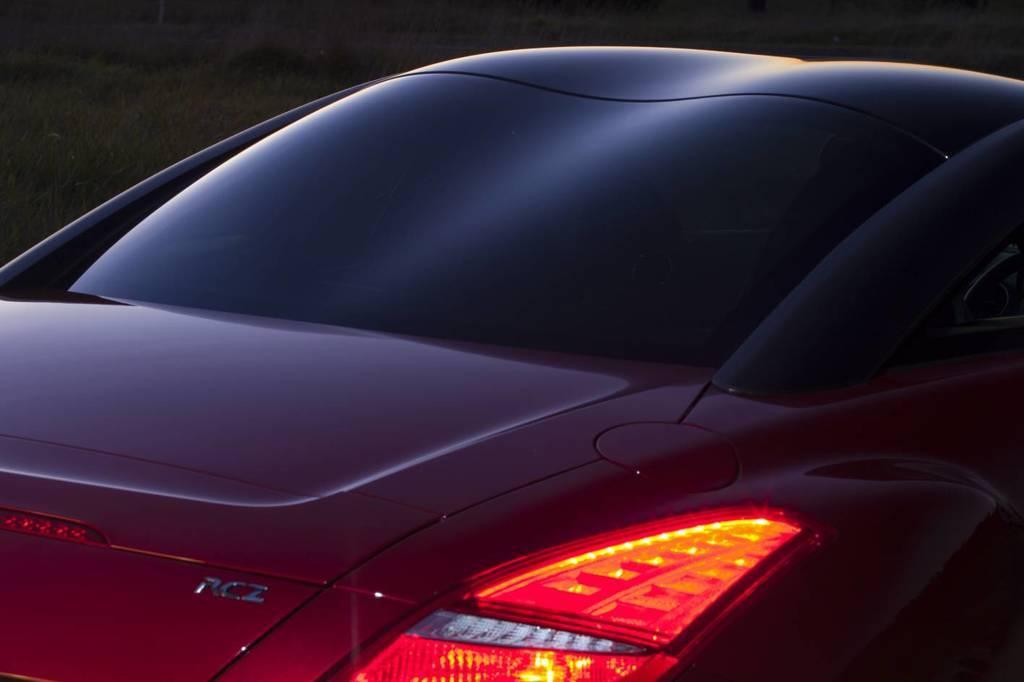Please provide a concise description of this image. In the image there is a car with lights and logo. And also there is a glass. Beside the car there is grass. 